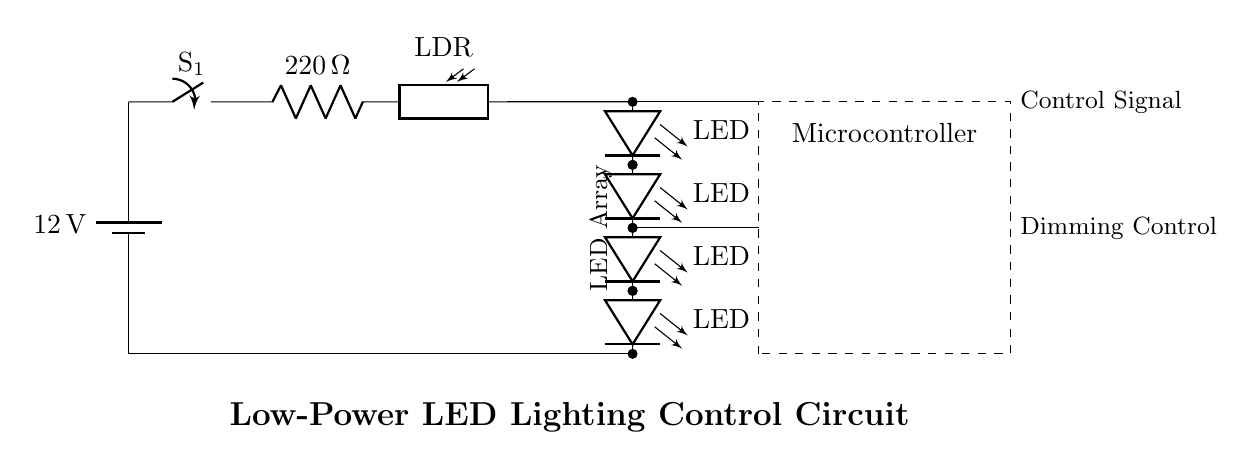What is the purpose of the photoresistor in the circuit? The photoresistor senses the ambient light levels and adjusts the circuit's operation based on the light, thereby controlling the brightness of the LED array.
Answer: Sensing light levels What is the rated voltage of the battery? The circuit diagram shows a battery labeled with a voltage of twelve volts, indicating the power supply for the entire circuit.
Answer: Twelve volts How many LEDs are in series in the array? The circuit diagram clearly depicts four LED components stacked vertically, connected in series from the lower side of the circuit.
Answer: Four What is the function of the current limiting resistor? The 220 ohm resistor is in series with the LEDs to limit the current flowing to the LED array, preventing damage due to excess current.
Answer: Limit current What component controls the LED brightness? The microcontroller, shown in the dashed box, is responsible for processing input from the photoresistor and controlling the LED brightness accordingly through dimming control.
Answer: Microcontroller What type of circuit is this? This is a low-power LED lighting control circuit, designed specifically for energy efficiency in common areas, utilizing low-power components.
Answer: Low-power LED lighting control circuit 